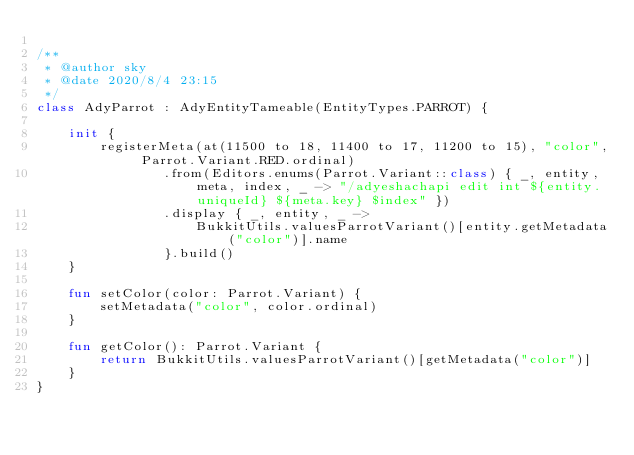Convert code to text. <code><loc_0><loc_0><loc_500><loc_500><_Kotlin_>
/**
 * @author sky
 * @date 2020/8/4 23:15
 */
class AdyParrot : AdyEntityTameable(EntityTypes.PARROT) {

    init {
        registerMeta(at(11500 to 18, 11400 to 17, 11200 to 15), "color", Parrot.Variant.RED.ordinal)
                .from(Editors.enums(Parrot.Variant::class) { _, entity, meta, index, _ -> "/adyeshachapi edit int ${entity.uniqueId} ${meta.key} $index" })
                .display { _, entity, _ ->
                    BukkitUtils.valuesParrotVariant()[entity.getMetadata("color")].name
                }.build()
    }

    fun setColor(color: Parrot.Variant) {
        setMetadata("color", color.ordinal)
    }

    fun getColor(): Parrot.Variant {
        return BukkitUtils.valuesParrotVariant()[getMetadata("color")]
    }
}
</code> 